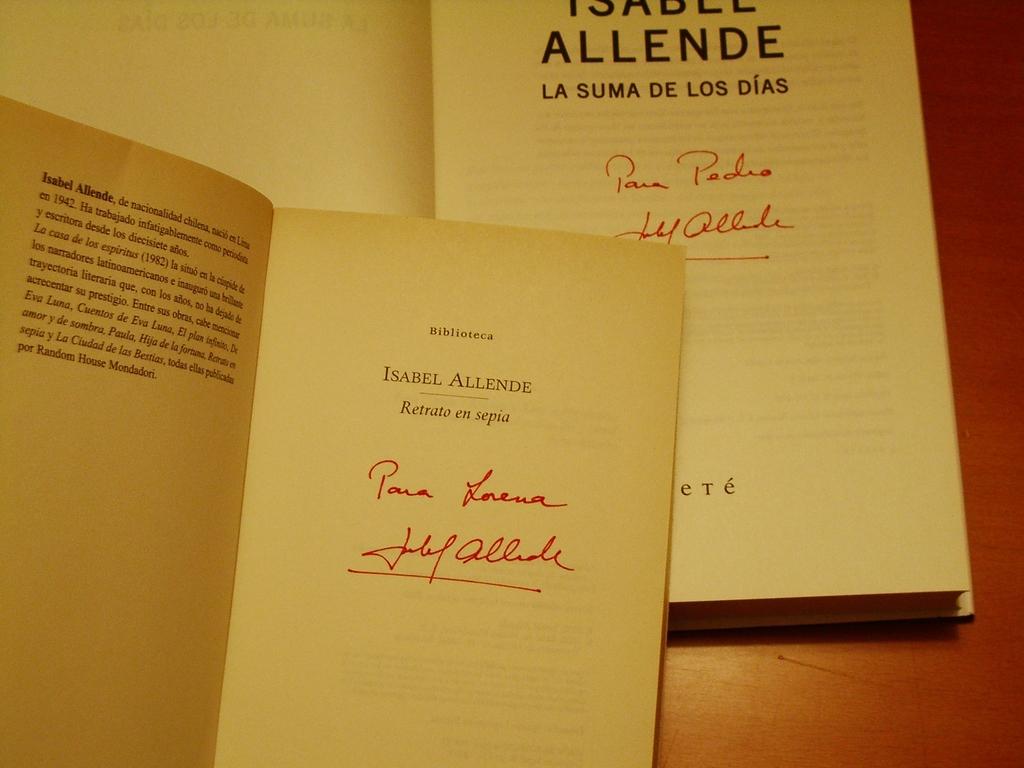Who is the author of these books?
Your answer should be very brief. Isabel allende. 